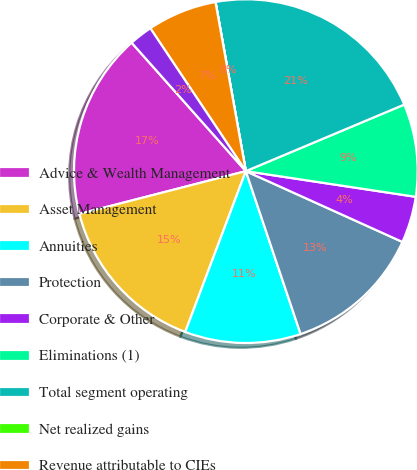Convert chart. <chart><loc_0><loc_0><loc_500><loc_500><pie_chart><fcel>Advice & Wealth Management<fcel>Asset Management<fcel>Annuities<fcel>Protection<fcel>Corporate & Other<fcel>Eliminations (1)<fcel>Total segment operating<fcel>Net realized gains<fcel>Revenue attributable to CIEs<fcel>Market impact on IUL benefits<nl><fcel>17.44%<fcel>15.26%<fcel>10.9%<fcel>13.08%<fcel>4.37%<fcel>8.72%<fcel>21.49%<fcel>0.01%<fcel>6.55%<fcel>2.19%<nl></chart> 